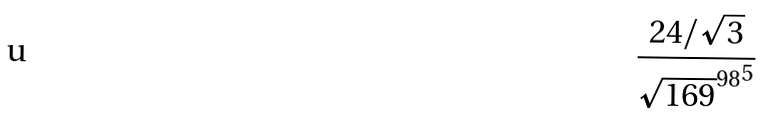<formula> <loc_0><loc_0><loc_500><loc_500>\frac { 2 4 / \sqrt { 3 } } { { \sqrt { 1 6 9 } ^ { 9 8 } } ^ { 5 } }</formula> 